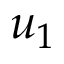<formula> <loc_0><loc_0><loc_500><loc_500>u _ { 1 }</formula> 